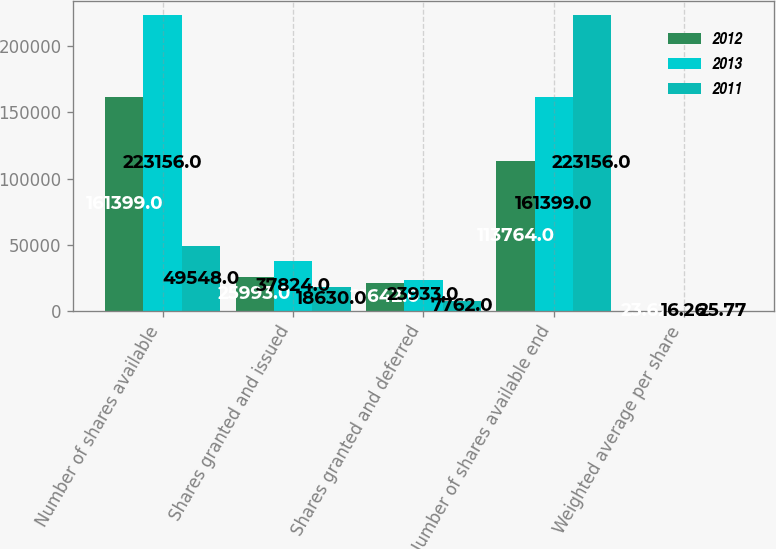<chart> <loc_0><loc_0><loc_500><loc_500><stacked_bar_chart><ecel><fcel>Number of shares available<fcel>Shares granted and issued<fcel>Shares granted and deferred<fcel>Number of shares available end<fcel>Weighted average per share<nl><fcel>2012<fcel>161399<fcel>25993<fcel>21642<fcel>113764<fcel>23.62<nl><fcel>2013<fcel>223156<fcel>37824<fcel>23933<fcel>161399<fcel>16.26<nl><fcel>2011<fcel>49548<fcel>18630<fcel>7762<fcel>223156<fcel>25.77<nl></chart> 